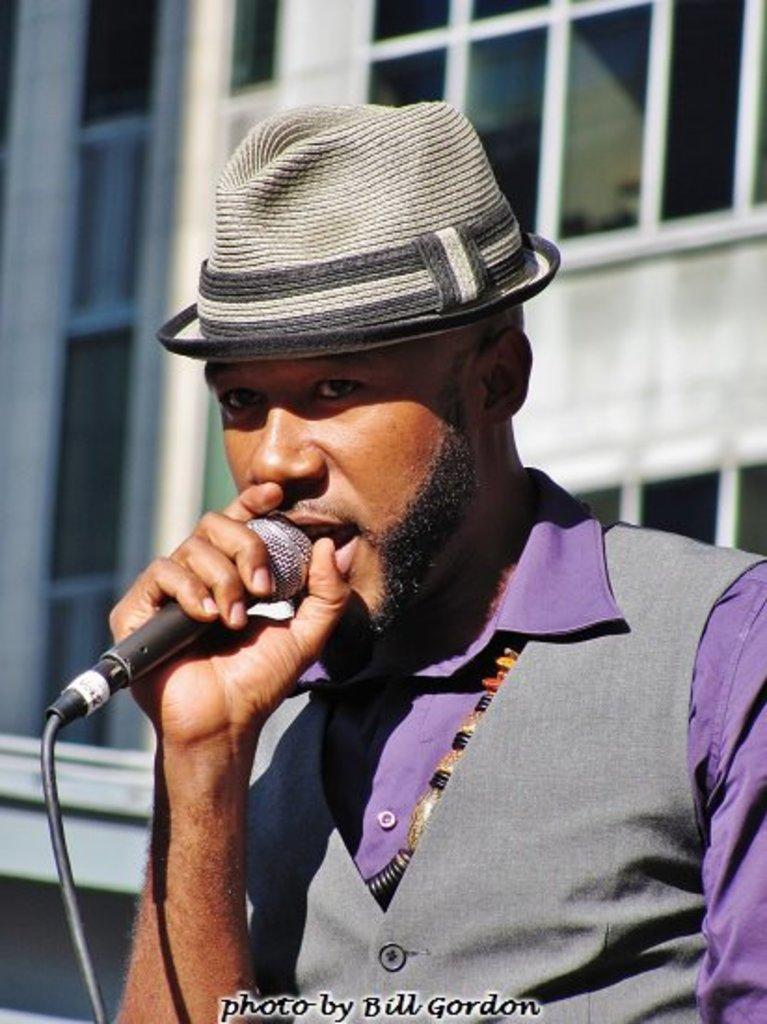Who is present in the image? There is a man in the image. What is the man holding in the image? The man is holding a microphone. What is the man wearing in the image? The man is wearing clothes and a hat. What can be seen in the background of the image? There is a window in the image. What type of basketball is the man dribbling in the image? There is no basketball present in the image; the man is holding a microphone. How does the man's tongue affect the sound quality of the microphone in the image? The man's tongue is not visible in the image, and there is no indication that it would affect the sound quality of the microphone. 